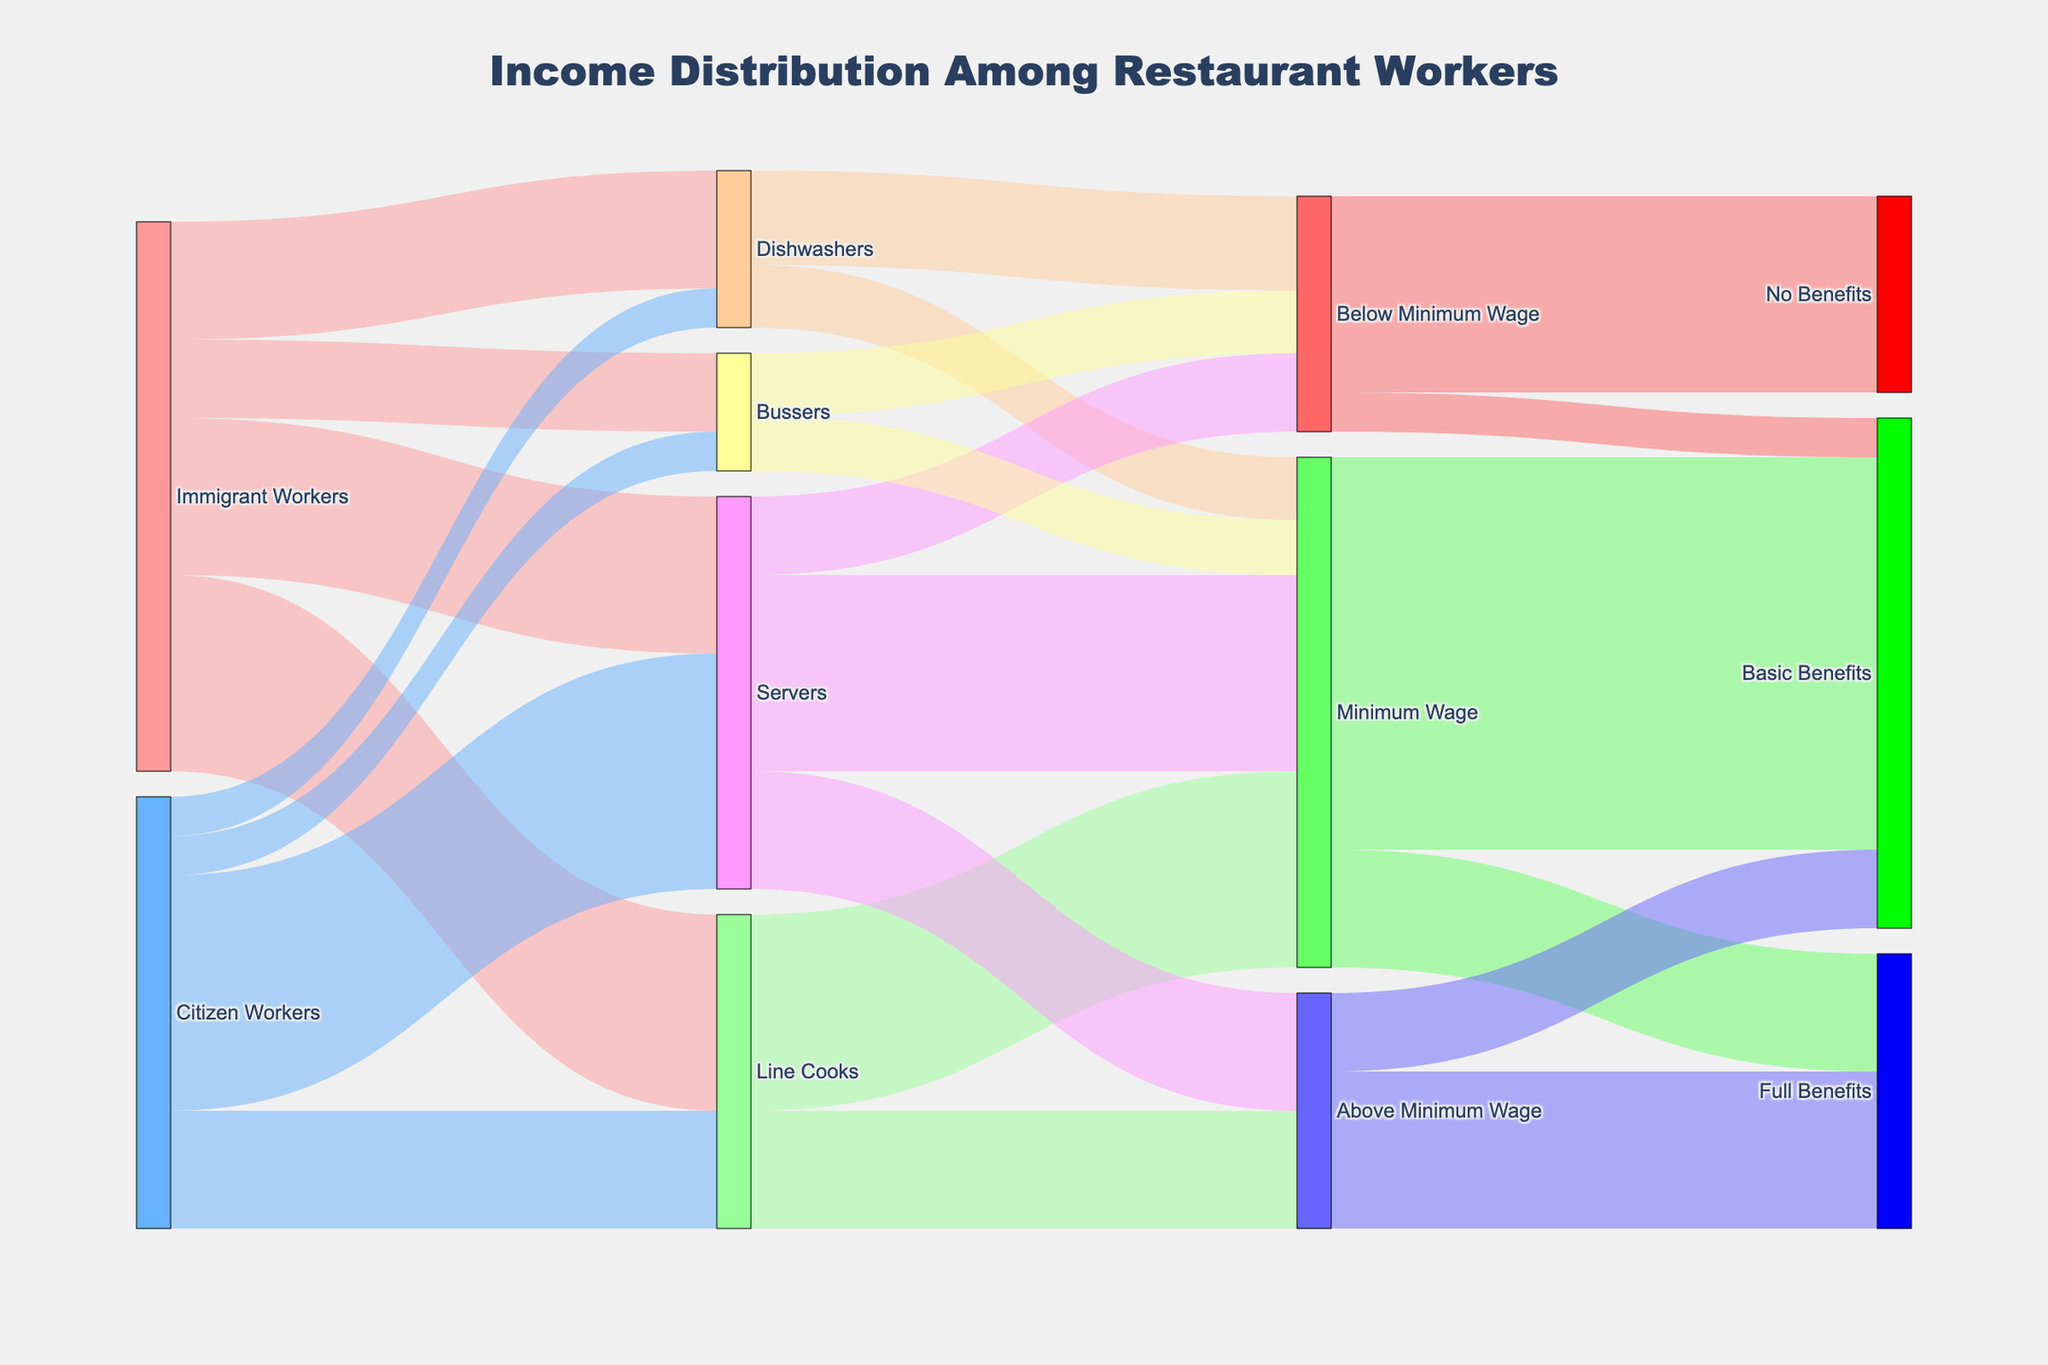What is the title of the figure? The title is clearly visible at the top of the figure. It reads "Income Distribution Among Restaurant Workers".
Answer: Income Distribution Among Restaurant Workers What color represents Immigrant Workers? Immigrant Workers are represented by the node colored in a shade of red.
Answer: Red How many Immigrant Workers are Servers? Look for the branch from "Immigrant Workers" to "Servers". The value in this link is 20.
Answer: 20 Which group has more workers as Line Cooks, Immigrant Workers or Citizen Workers? Compare the values in the links from "Immigrant Workers" and "Citizen Workers" to "Line Cooks". Immigrant Workers have 25, while Citizen Workers have 15.
Answer: Immigrant Workers Among Bussers, how many receive Minimum Wage? Look for the links from "Bussers" to "Minimum Wage". The value in this link is 7.
Answer: 7 Which job role has the highest number of Immigrant Workers? Look at the values of all links from "Immigrant Workers" to job roles. Line Cooks have the highest value of 25.
Answer: Line Cooks What percentage of Dishwashers are Citizen Workers? Combine the values for Dishwashers from Immigrant and Citizen Workers (15 + 5 = 20). Citizen Workers are 5 out of this total. The percentage is calculated as (5/20) * 100.
Answer: 25% For which wage category do most Servers fall? Look at the values of links from "Servers" to wage categories. "Minimum Wage" has the highest value of 25.
Answer: Minimum Wage What's the total number of workers earning Above Minimum Wage? Sum the values linked to "Above Minimum Wage" from all job roles: 15 (Line Cooks) + 15 (Servers) = 30.
Answer: 30 How many workers are earning Below Minimum Wage without any benefits? Look for the link from "Below Minimum Wage" to "No Benefits". The value in this link is 25.
Answer: 25 